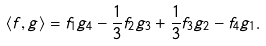<formula> <loc_0><loc_0><loc_500><loc_500>\langle f , g \rangle = f _ { 1 } g _ { 4 } - \frac { 1 } { 3 } f _ { 2 } g _ { 3 } + \frac { 1 } { 3 } f _ { 3 } g _ { 2 } - f _ { 4 } g _ { 1 } .</formula> 